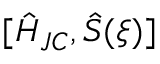<formula> <loc_0><loc_0><loc_500><loc_500>[ \hat { H } _ { J C } , \hat { S } ( \xi ) ]</formula> 